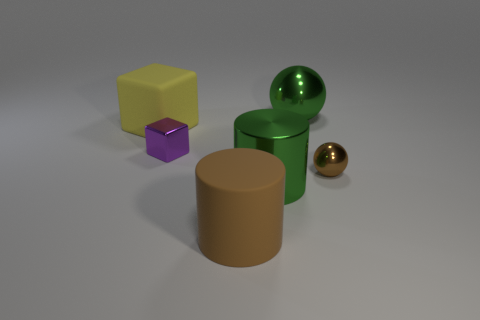What is the shape of the big green metal object behind the green object in front of the small object that is to the right of the large brown cylinder? sphere 